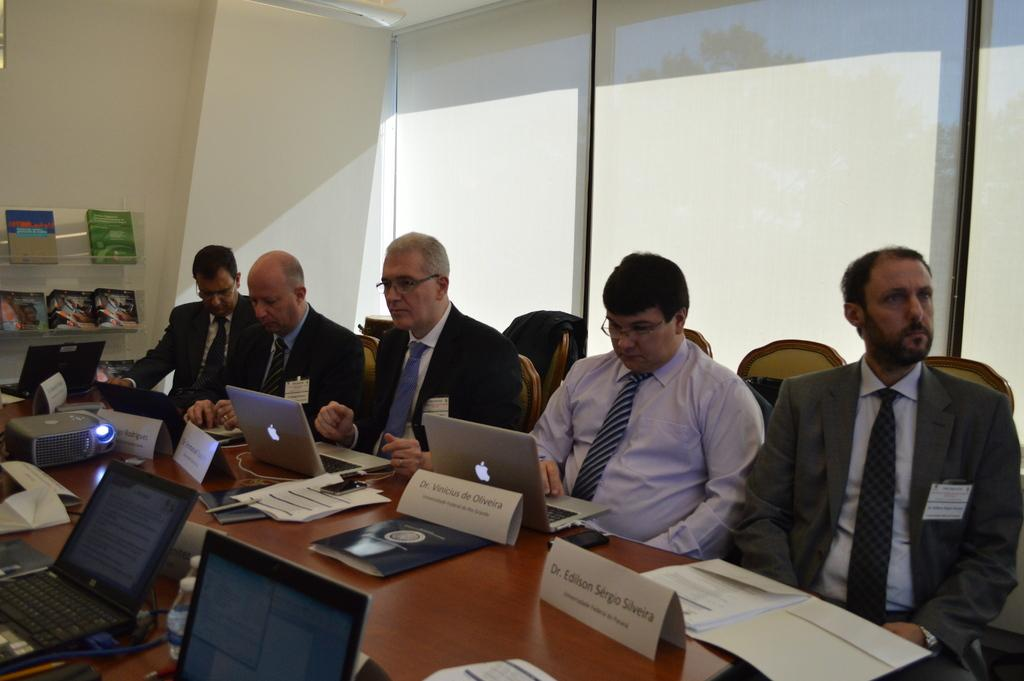How many people are in the room? There are people in the room, but the exact number is not specified. What are the people doing in the room? The people are sitting on chairs and working on laptops. Where are the laptops placed in relation to the people? The laptops are placed on tables in front of the people. How many geese are present in the room? There is no mention of geese in the provided facts, so we cannot determine their presence in the room. 